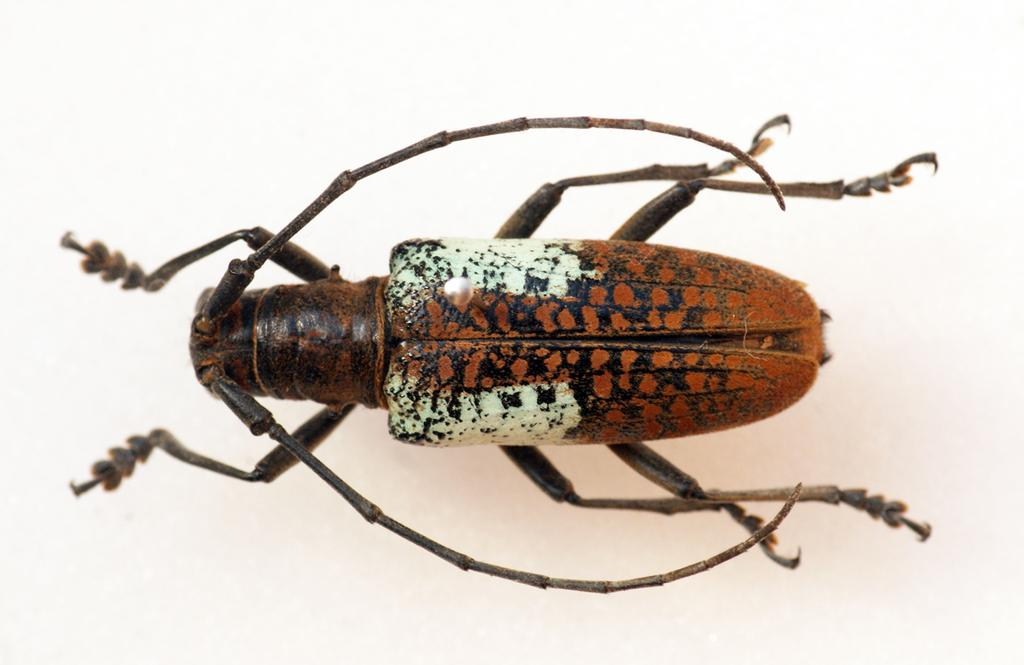What type of image is being described? The image is a closed picture, meaning it is a still image and not a video or animation. What insect can be seen in the image? A longhorn beetle is present in the image. What is the background or surface on which the beetle is located? The beetle is on a white surface. What type of horse is depicted in the image? There is no horse present in the image; it features a longhorn beetle on a white surface. What type of bottle can be seen in the image? There is no bottle present in the image; it features a longhorn beetle on a white surface. 